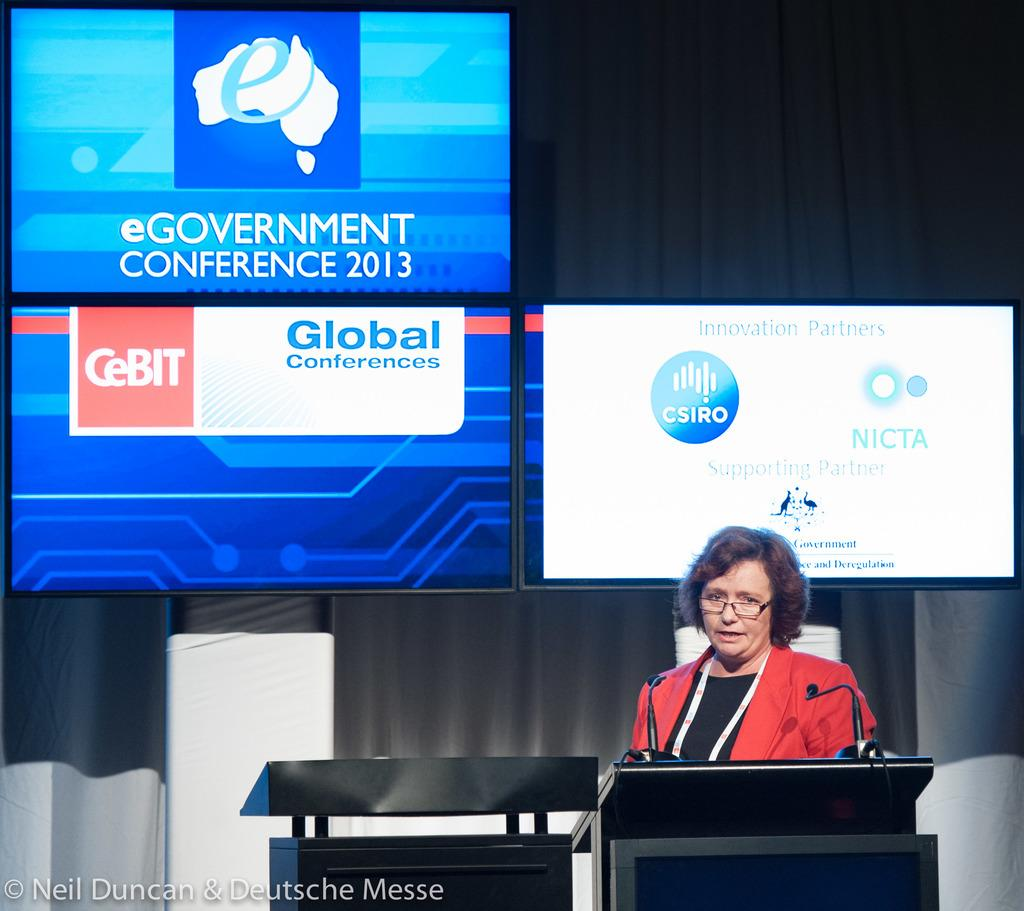<image>
Summarize the visual content of the image. Woman giving a presentation in front of a screen that says NICTA. 